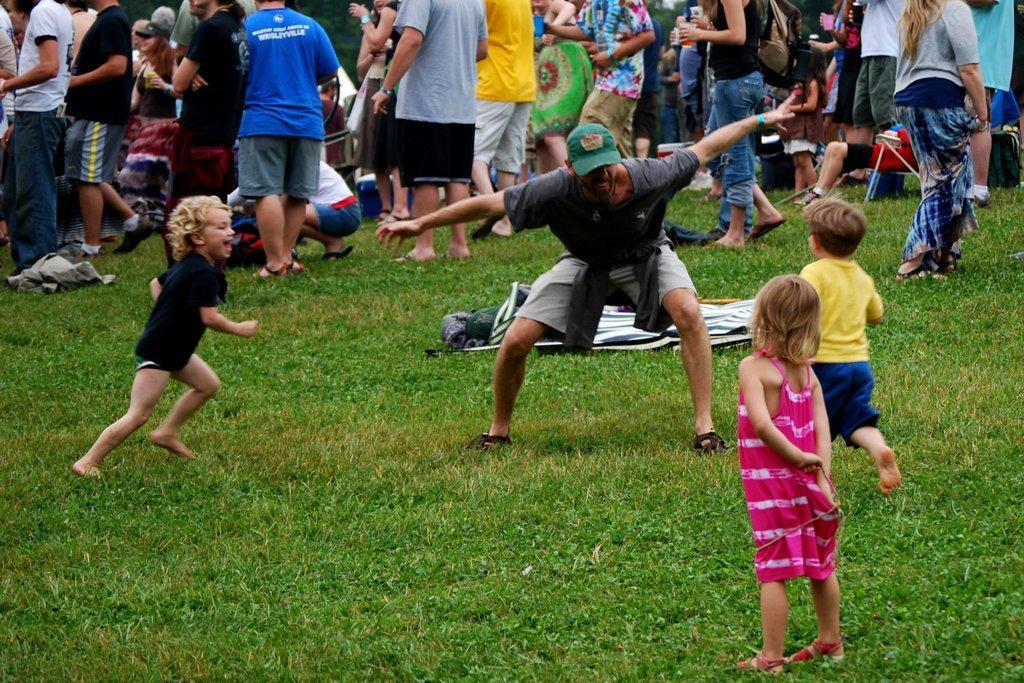In one or two sentences, can you explain what this image depicts? In this picture I can see 3 children and a man in front who are standing and I see the grass. In the background I see number of people. 